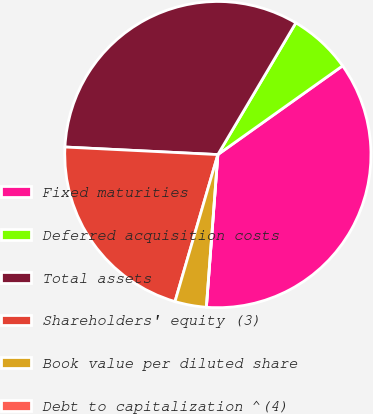Convert chart. <chart><loc_0><loc_0><loc_500><loc_500><pie_chart><fcel>Fixed maturities<fcel>Deferred acquisition costs<fcel>Total assets<fcel>Shareholders' equity (3)<fcel>Book value per diluted share<fcel>Debt to capitalization ^(4)<nl><fcel>36.04%<fcel>6.65%<fcel>32.72%<fcel>21.27%<fcel>3.32%<fcel>0.0%<nl></chart> 